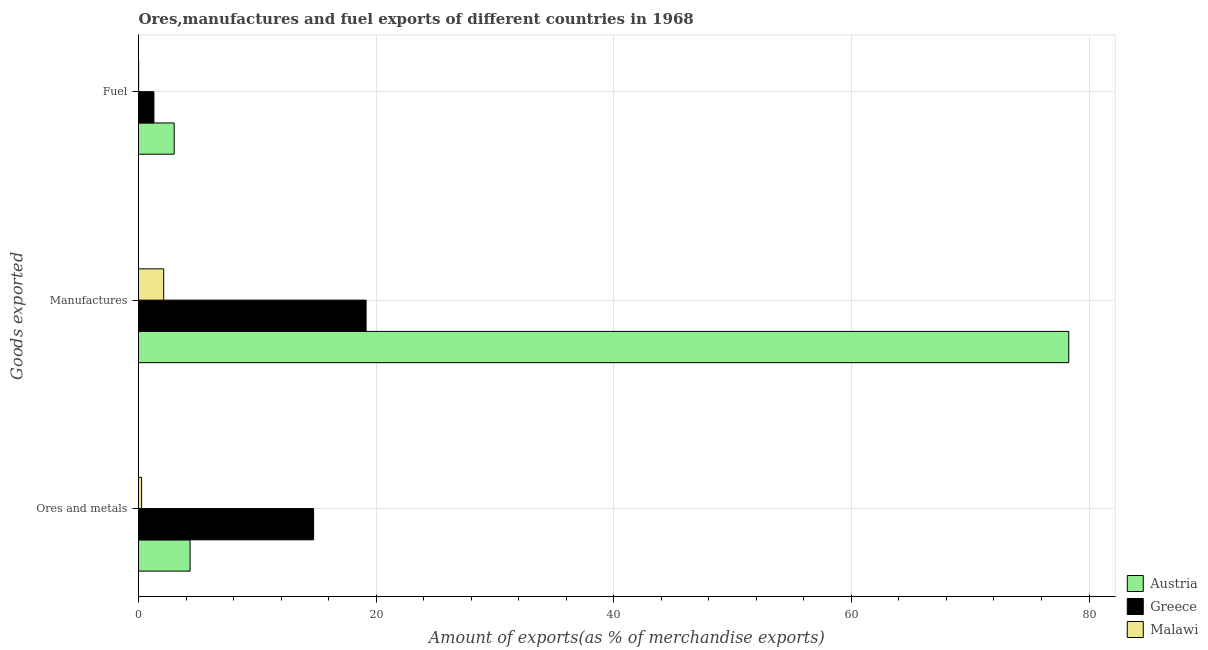How many different coloured bars are there?
Your answer should be compact. 3. How many groups of bars are there?
Provide a succinct answer. 3. Are the number of bars per tick equal to the number of legend labels?
Your answer should be compact. Yes. Are the number of bars on each tick of the Y-axis equal?
Offer a terse response. Yes. How many bars are there on the 2nd tick from the bottom?
Offer a very short reply. 3. What is the label of the 3rd group of bars from the top?
Make the answer very short. Ores and metals. What is the percentage of fuel exports in Austria?
Give a very brief answer. 3. Across all countries, what is the maximum percentage of ores and metals exports?
Offer a terse response. 14.74. Across all countries, what is the minimum percentage of manufactures exports?
Offer a very short reply. 2.12. In which country was the percentage of manufactures exports minimum?
Ensure brevity in your answer.  Malawi. What is the total percentage of manufactures exports in the graph?
Your response must be concise. 99.57. What is the difference between the percentage of fuel exports in Greece and that in Malawi?
Offer a terse response. 1.28. What is the difference between the percentage of fuel exports in Austria and the percentage of ores and metals exports in Greece?
Provide a succinct answer. -11.73. What is the average percentage of manufactures exports per country?
Offer a terse response. 33.19. What is the difference between the percentage of fuel exports and percentage of manufactures exports in Malawi?
Make the answer very short. -2.11. In how many countries, is the percentage of ores and metals exports greater than 60 %?
Provide a succinct answer. 0. What is the ratio of the percentage of fuel exports in Austria to that in Malawi?
Offer a very short reply. 245.1. Is the difference between the percentage of manufactures exports in Austria and Malawi greater than the difference between the percentage of fuel exports in Austria and Malawi?
Make the answer very short. Yes. What is the difference between the highest and the second highest percentage of manufactures exports?
Give a very brief answer. 59.14. What is the difference between the highest and the lowest percentage of fuel exports?
Your response must be concise. 2.99. In how many countries, is the percentage of manufactures exports greater than the average percentage of manufactures exports taken over all countries?
Offer a very short reply. 1. Is the sum of the percentage of manufactures exports in Greece and Austria greater than the maximum percentage of fuel exports across all countries?
Ensure brevity in your answer.  Yes. What does the 3rd bar from the top in Manufactures represents?
Keep it short and to the point. Austria. How many bars are there?
Offer a very short reply. 9. Are all the bars in the graph horizontal?
Give a very brief answer. Yes. Are the values on the major ticks of X-axis written in scientific E-notation?
Offer a very short reply. No. Does the graph contain any zero values?
Provide a short and direct response. No. Does the graph contain grids?
Your answer should be compact. Yes. How many legend labels are there?
Ensure brevity in your answer.  3. What is the title of the graph?
Offer a terse response. Ores,manufactures and fuel exports of different countries in 1968. Does "Central Europe" appear as one of the legend labels in the graph?
Keep it short and to the point. No. What is the label or title of the X-axis?
Make the answer very short. Amount of exports(as % of merchandise exports). What is the label or title of the Y-axis?
Your response must be concise. Goods exported. What is the Amount of exports(as % of merchandise exports) in Austria in Ores and metals?
Make the answer very short. 4.34. What is the Amount of exports(as % of merchandise exports) in Greece in Ores and metals?
Offer a terse response. 14.74. What is the Amount of exports(as % of merchandise exports) of Malawi in Ores and metals?
Ensure brevity in your answer.  0.26. What is the Amount of exports(as % of merchandise exports) in Austria in Manufactures?
Make the answer very short. 78.29. What is the Amount of exports(as % of merchandise exports) of Greece in Manufactures?
Your response must be concise. 19.15. What is the Amount of exports(as % of merchandise exports) in Malawi in Manufactures?
Your answer should be compact. 2.12. What is the Amount of exports(as % of merchandise exports) in Austria in Fuel?
Make the answer very short. 3. What is the Amount of exports(as % of merchandise exports) of Greece in Fuel?
Your answer should be compact. 1.3. What is the Amount of exports(as % of merchandise exports) of Malawi in Fuel?
Make the answer very short. 0.01. Across all Goods exported, what is the maximum Amount of exports(as % of merchandise exports) in Austria?
Give a very brief answer. 78.29. Across all Goods exported, what is the maximum Amount of exports(as % of merchandise exports) of Greece?
Ensure brevity in your answer.  19.15. Across all Goods exported, what is the maximum Amount of exports(as % of merchandise exports) of Malawi?
Offer a very short reply. 2.12. Across all Goods exported, what is the minimum Amount of exports(as % of merchandise exports) in Austria?
Your answer should be compact. 3. Across all Goods exported, what is the minimum Amount of exports(as % of merchandise exports) in Greece?
Give a very brief answer. 1.3. Across all Goods exported, what is the minimum Amount of exports(as % of merchandise exports) in Malawi?
Offer a terse response. 0.01. What is the total Amount of exports(as % of merchandise exports) of Austria in the graph?
Ensure brevity in your answer.  85.64. What is the total Amount of exports(as % of merchandise exports) in Greece in the graph?
Ensure brevity in your answer.  35.19. What is the total Amount of exports(as % of merchandise exports) in Malawi in the graph?
Make the answer very short. 2.39. What is the difference between the Amount of exports(as % of merchandise exports) of Austria in Ores and metals and that in Manufactures?
Your answer should be very brief. -73.95. What is the difference between the Amount of exports(as % of merchandise exports) in Greece in Ores and metals and that in Manufactures?
Make the answer very short. -4.42. What is the difference between the Amount of exports(as % of merchandise exports) in Malawi in Ores and metals and that in Manufactures?
Provide a short and direct response. -1.86. What is the difference between the Amount of exports(as % of merchandise exports) of Austria in Ores and metals and that in Fuel?
Keep it short and to the point. 1.34. What is the difference between the Amount of exports(as % of merchandise exports) in Greece in Ores and metals and that in Fuel?
Your response must be concise. 13.44. What is the difference between the Amount of exports(as % of merchandise exports) in Malawi in Ores and metals and that in Fuel?
Make the answer very short. 0.25. What is the difference between the Amount of exports(as % of merchandise exports) in Austria in Manufactures and that in Fuel?
Provide a succinct answer. 75.29. What is the difference between the Amount of exports(as % of merchandise exports) of Greece in Manufactures and that in Fuel?
Give a very brief answer. 17.86. What is the difference between the Amount of exports(as % of merchandise exports) of Malawi in Manufactures and that in Fuel?
Keep it short and to the point. 2.11. What is the difference between the Amount of exports(as % of merchandise exports) of Austria in Ores and metals and the Amount of exports(as % of merchandise exports) of Greece in Manufactures?
Your answer should be very brief. -14.81. What is the difference between the Amount of exports(as % of merchandise exports) in Austria in Ores and metals and the Amount of exports(as % of merchandise exports) in Malawi in Manufactures?
Your response must be concise. 2.22. What is the difference between the Amount of exports(as % of merchandise exports) in Greece in Ores and metals and the Amount of exports(as % of merchandise exports) in Malawi in Manufactures?
Your answer should be very brief. 12.62. What is the difference between the Amount of exports(as % of merchandise exports) of Austria in Ores and metals and the Amount of exports(as % of merchandise exports) of Greece in Fuel?
Make the answer very short. 3.05. What is the difference between the Amount of exports(as % of merchandise exports) of Austria in Ores and metals and the Amount of exports(as % of merchandise exports) of Malawi in Fuel?
Provide a succinct answer. 4.33. What is the difference between the Amount of exports(as % of merchandise exports) of Greece in Ores and metals and the Amount of exports(as % of merchandise exports) of Malawi in Fuel?
Make the answer very short. 14.73. What is the difference between the Amount of exports(as % of merchandise exports) of Austria in Manufactures and the Amount of exports(as % of merchandise exports) of Greece in Fuel?
Provide a succinct answer. 77. What is the difference between the Amount of exports(as % of merchandise exports) of Austria in Manufactures and the Amount of exports(as % of merchandise exports) of Malawi in Fuel?
Provide a short and direct response. 78.28. What is the difference between the Amount of exports(as % of merchandise exports) in Greece in Manufactures and the Amount of exports(as % of merchandise exports) in Malawi in Fuel?
Provide a succinct answer. 19.14. What is the average Amount of exports(as % of merchandise exports) in Austria per Goods exported?
Your answer should be compact. 28.55. What is the average Amount of exports(as % of merchandise exports) in Greece per Goods exported?
Provide a succinct answer. 11.73. What is the average Amount of exports(as % of merchandise exports) in Malawi per Goods exported?
Your answer should be very brief. 0.8. What is the difference between the Amount of exports(as % of merchandise exports) in Austria and Amount of exports(as % of merchandise exports) in Greece in Ores and metals?
Provide a succinct answer. -10.39. What is the difference between the Amount of exports(as % of merchandise exports) in Austria and Amount of exports(as % of merchandise exports) in Malawi in Ores and metals?
Provide a short and direct response. 4.08. What is the difference between the Amount of exports(as % of merchandise exports) in Greece and Amount of exports(as % of merchandise exports) in Malawi in Ores and metals?
Keep it short and to the point. 14.48. What is the difference between the Amount of exports(as % of merchandise exports) in Austria and Amount of exports(as % of merchandise exports) in Greece in Manufactures?
Give a very brief answer. 59.14. What is the difference between the Amount of exports(as % of merchandise exports) in Austria and Amount of exports(as % of merchandise exports) in Malawi in Manufactures?
Ensure brevity in your answer.  76.17. What is the difference between the Amount of exports(as % of merchandise exports) in Greece and Amount of exports(as % of merchandise exports) in Malawi in Manufactures?
Provide a succinct answer. 17.03. What is the difference between the Amount of exports(as % of merchandise exports) in Austria and Amount of exports(as % of merchandise exports) in Greece in Fuel?
Offer a terse response. 1.71. What is the difference between the Amount of exports(as % of merchandise exports) in Austria and Amount of exports(as % of merchandise exports) in Malawi in Fuel?
Your answer should be compact. 2.99. What is the difference between the Amount of exports(as % of merchandise exports) in Greece and Amount of exports(as % of merchandise exports) in Malawi in Fuel?
Keep it short and to the point. 1.28. What is the ratio of the Amount of exports(as % of merchandise exports) of Austria in Ores and metals to that in Manufactures?
Your answer should be compact. 0.06. What is the ratio of the Amount of exports(as % of merchandise exports) of Greece in Ores and metals to that in Manufactures?
Your response must be concise. 0.77. What is the ratio of the Amount of exports(as % of merchandise exports) of Malawi in Ores and metals to that in Manufactures?
Ensure brevity in your answer.  0.12. What is the ratio of the Amount of exports(as % of merchandise exports) in Austria in Ores and metals to that in Fuel?
Ensure brevity in your answer.  1.45. What is the ratio of the Amount of exports(as % of merchandise exports) of Greece in Ores and metals to that in Fuel?
Offer a very short reply. 11.36. What is the ratio of the Amount of exports(as % of merchandise exports) in Malawi in Ores and metals to that in Fuel?
Ensure brevity in your answer.  21.35. What is the ratio of the Amount of exports(as % of merchandise exports) of Austria in Manufactures to that in Fuel?
Keep it short and to the point. 26.07. What is the ratio of the Amount of exports(as % of merchandise exports) in Greece in Manufactures to that in Fuel?
Your answer should be very brief. 14.77. What is the ratio of the Amount of exports(as % of merchandise exports) in Malawi in Manufactures to that in Fuel?
Keep it short and to the point. 173.11. What is the difference between the highest and the second highest Amount of exports(as % of merchandise exports) in Austria?
Provide a succinct answer. 73.95. What is the difference between the highest and the second highest Amount of exports(as % of merchandise exports) in Greece?
Your answer should be very brief. 4.42. What is the difference between the highest and the second highest Amount of exports(as % of merchandise exports) in Malawi?
Give a very brief answer. 1.86. What is the difference between the highest and the lowest Amount of exports(as % of merchandise exports) in Austria?
Ensure brevity in your answer.  75.29. What is the difference between the highest and the lowest Amount of exports(as % of merchandise exports) of Greece?
Offer a very short reply. 17.86. What is the difference between the highest and the lowest Amount of exports(as % of merchandise exports) of Malawi?
Make the answer very short. 2.11. 